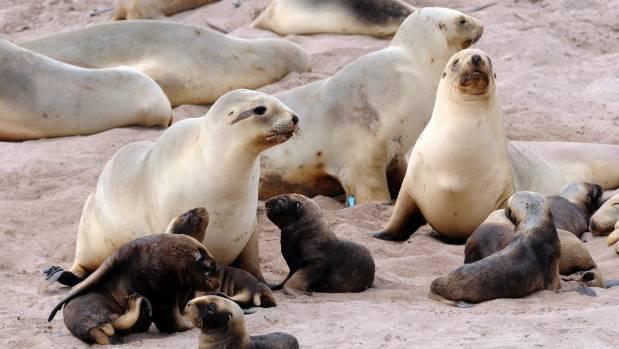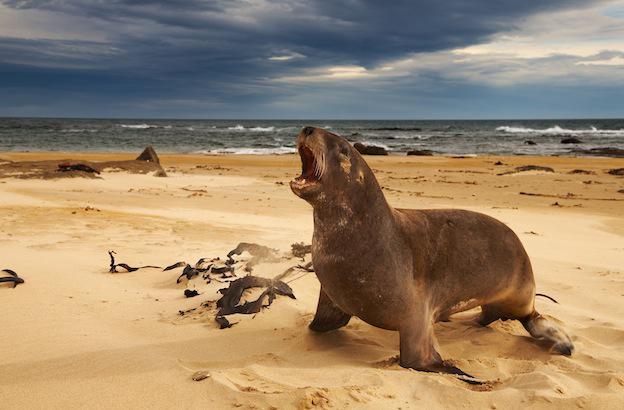The first image is the image on the left, the second image is the image on the right. For the images shown, is this caption "There are no more than five sea animals on the shore." true? Answer yes or no. No. The first image is the image on the left, the second image is the image on the right. Given the left and right images, does the statement "An image shows exactly two seals, both with their mouths opened." hold true? Answer yes or no. No. 